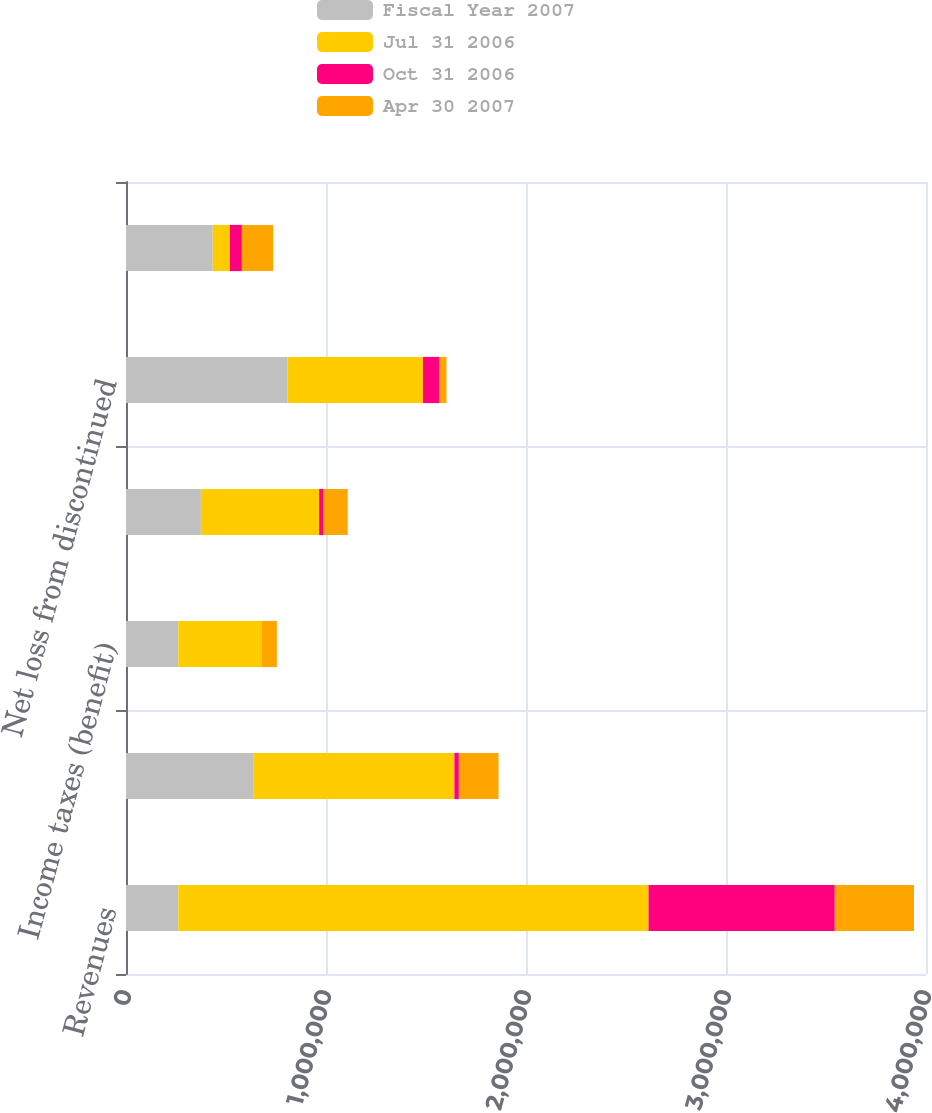Convert chart to OTSL. <chart><loc_0><loc_0><loc_500><loc_500><stacked_bar_chart><ecel><fcel>Revenues<fcel>Income (loss) from continuing<fcel>Income taxes (benefit)<fcel>Net income (loss) from<fcel>Net loss from discontinued<fcel>Net loss<nl><fcel>Fiscal Year 2007<fcel>261461<fcel>635798<fcel>261461<fcel>374337<fcel>807990<fcel>433653<nl><fcel>Jul 31 2006<fcel>2.35124e+06<fcel>1.00627e+06<fcel>415037<fcel>591229<fcel>676793<fcel>85564<nl><fcel>Oct 31 2006<fcel>931179<fcel>22125<fcel>181<fcel>21944<fcel>82196<fcel>60252<nl><fcel>Apr 30 2007<fcel>396083<fcel>198619<fcel>77622<fcel>120997<fcel>35463<fcel>156460<nl></chart> 